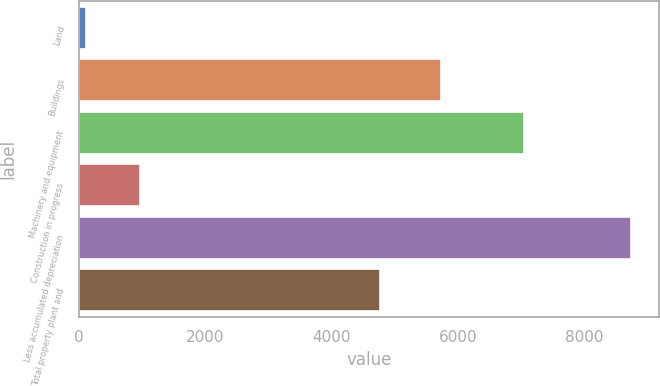Convert chart. <chart><loc_0><loc_0><loc_500><loc_500><bar_chart><fcel>Land<fcel>Buildings<fcel>Machinery and equipment<fcel>Construction in progress<fcel>Less accumulated depreciation<fcel>Total property plant and<nl><fcel>99<fcel>5724<fcel>7036<fcel>963.1<fcel>8740<fcel>4755<nl></chart> 